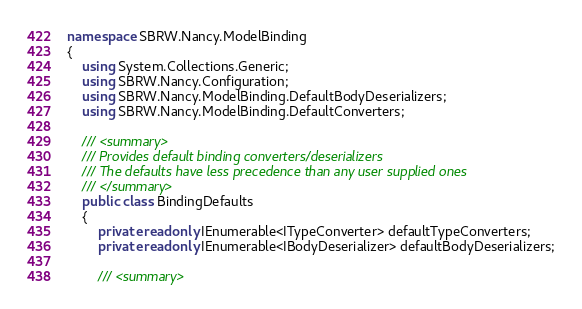<code> <loc_0><loc_0><loc_500><loc_500><_C#_>namespace SBRW.Nancy.ModelBinding
{
    using System.Collections.Generic;
    using SBRW.Nancy.Configuration;
    using SBRW.Nancy.ModelBinding.DefaultBodyDeserializers;
    using SBRW.Nancy.ModelBinding.DefaultConverters;

    /// <summary>
    /// Provides default binding converters/deserializers
    /// The defaults have less precedence than any user supplied ones
    /// </summary>
    public class BindingDefaults
    {
        private readonly IEnumerable<ITypeConverter> defaultTypeConverters;
        private readonly IEnumerable<IBodyDeserializer> defaultBodyDeserializers;

        /// <summary></code> 